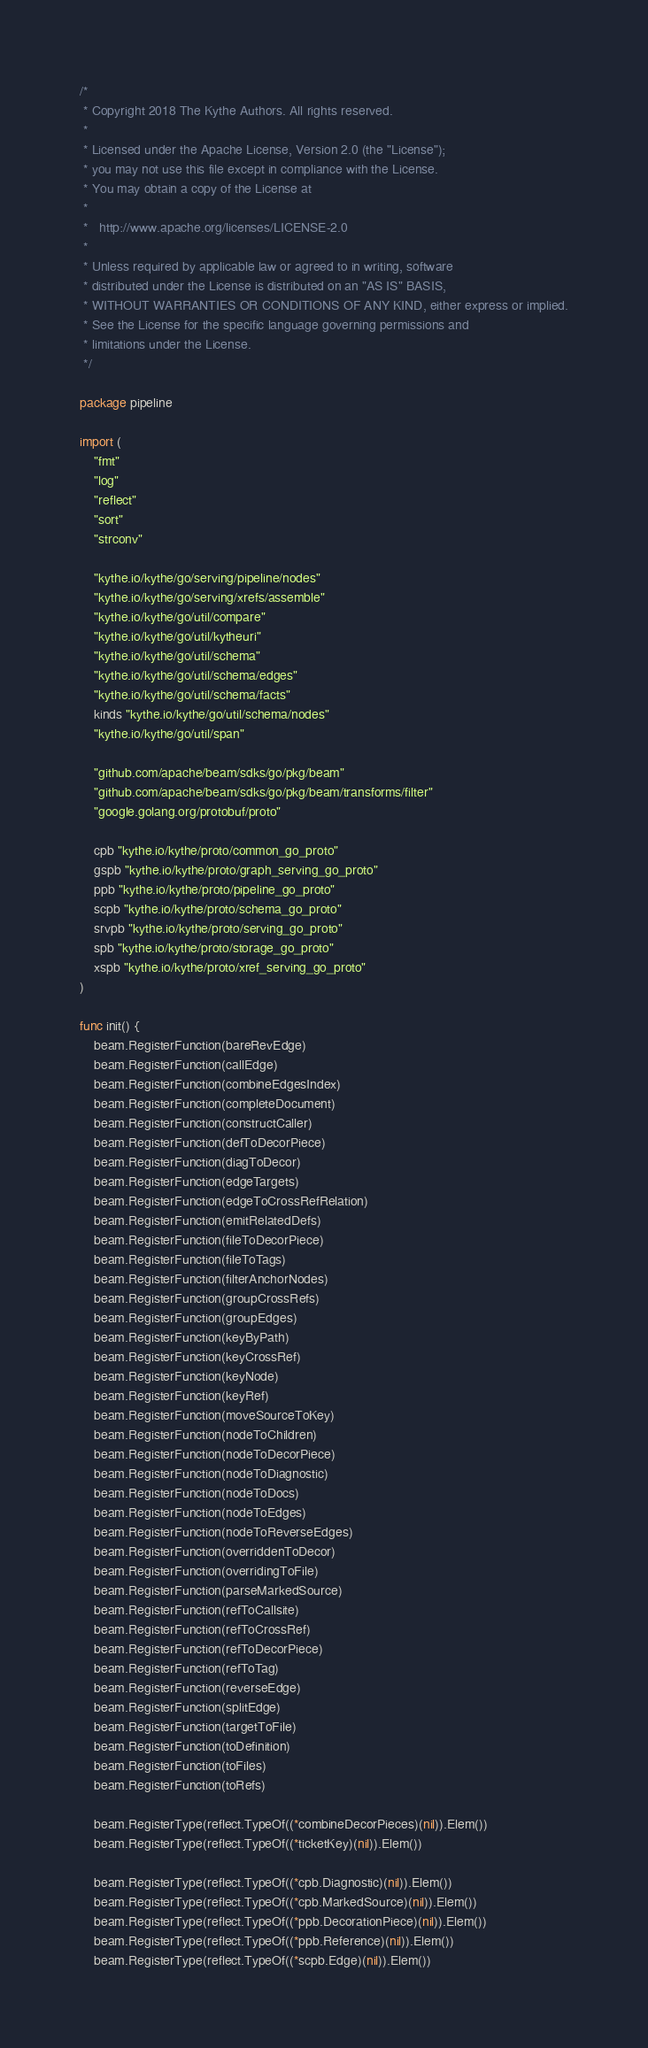Convert code to text. <code><loc_0><loc_0><loc_500><loc_500><_Go_>/*
 * Copyright 2018 The Kythe Authors. All rights reserved.
 *
 * Licensed under the Apache License, Version 2.0 (the "License");
 * you may not use this file except in compliance with the License.
 * You may obtain a copy of the License at
 *
 *   http://www.apache.org/licenses/LICENSE-2.0
 *
 * Unless required by applicable law or agreed to in writing, software
 * distributed under the License is distributed on an "AS IS" BASIS,
 * WITHOUT WARRANTIES OR CONDITIONS OF ANY KIND, either express or implied.
 * See the License for the specific language governing permissions and
 * limitations under the License.
 */

package pipeline

import (
	"fmt"
	"log"
	"reflect"
	"sort"
	"strconv"

	"kythe.io/kythe/go/serving/pipeline/nodes"
	"kythe.io/kythe/go/serving/xrefs/assemble"
	"kythe.io/kythe/go/util/compare"
	"kythe.io/kythe/go/util/kytheuri"
	"kythe.io/kythe/go/util/schema"
	"kythe.io/kythe/go/util/schema/edges"
	"kythe.io/kythe/go/util/schema/facts"
	kinds "kythe.io/kythe/go/util/schema/nodes"
	"kythe.io/kythe/go/util/span"

	"github.com/apache/beam/sdks/go/pkg/beam"
	"github.com/apache/beam/sdks/go/pkg/beam/transforms/filter"
	"google.golang.org/protobuf/proto"

	cpb "kythe.io/kythe/proto/common_go_proto"
	gspb "kythe.io/kythe/proto/graph_serving_go_proto"
	ppb "kythe.io/kythe/proto/pipeline_go_proto"
	scpb "kythe.io/kythe/proto/schema_go_proto"
	srvpb "kythe.io/kythe/proto/serving_go_proto"
	spb "kythe.io/kythe/proto/storage_go_proto"
	xspb "kythe.io/kythe/proto/xref_serving_go_proto"
)

func init() {
	beam.RegisterFunction(bareRevEdge)
	beam.RegisterFunction(callEdge)
	beam.RegisterFunction(combineEdgesIndex)
	beam.RegisterFunction(completeDocument)
	beam.RegisterFunction(constructCaller)
	beam.RegisterFunction(defToDecorPiece)
	beam.RegisterFunction(diagToDecor)
	beam.RegisterFunction(edgeTargets)
	beam.RegisterFunction(edgeToCrossRefRelation)
	beam.RegisterFunction(emitRelatedDefs)
	beam.RegisterFunction(fileToDecorPiece)
	beam.RegisterFunction(fileToTags)
	beam.RegisterFunction(filterAnchorNodes)
	beam.RegisterFunction(groupCrossRefs)
	beam.RegisterFunction(groupEdges)
	beam.RegisterFunction(keyByPath)
	beam.RegisterFunction(keyCrossRef)
	beam.RegisterFunction(keyNode)
	beam.RegisterFunction(keyRef)
	beam.RegisterFunction(moveSourceToKey)
	beam.RegisterFunction(nodeToChildren)
	beam.RegisterFunction(nodeToDecorPiece)
	beam.RegisterFunction(nodeToDiagnostic)
	beam.RegisterFunction(nodeToDocs)
	beam.RegisterFunction(nodeToEdges)
	beam.RegisterFunction(nodeToReverseEdges)
	beam.RegisterFunction(overriddenToDecor)
	beam.RegisterFunction(overridingToFile)
	beam.RegisterFunction(parseMarkedSource)
	beam.RegisterFunction(refToCallsite)
	beam.RegisterFunction(refToCrossRef)
	beam.RegisterFunction(refToDecorPiece)
	beam.RegisterFunction(refToTag)
	beam.RegisterFunction(reverseEdge)
	beam.RegisterFunction(splitEdge)
	beam.RegisterFunction(targetToFile)
	beam.RegisterFunction(toDefinition)
	beam.RegisterFunction(toFiles)
	beam.RegisterFunction(toRefs)

	beam.RegisterType(reflect.TypeOf((*combineDecorPieces)(nil)).Elem())
	beam.RegisterType(reflect.TypeOf((*ticketKey)(nil)).Elem())

	beam.RegisterType(reflect.TypeOf((*cpb.Diagnostic)(nil)).Elem())
	beam.RegisterType(reflect.TypeOf((*cpb.MarkedSource)(nil)).Elem())
	beam.RegisterType(reflect.TypeOf((*ppb.DecorationPiece)(nil)).Elem())
	beam.RegisterType(reflect.TypeOf((*ppb.Reference)(nil)).Elem())
	beam.RegisterType(reflect.TypeOf((*scpb.Edge)(nil)).Elem())</code> 